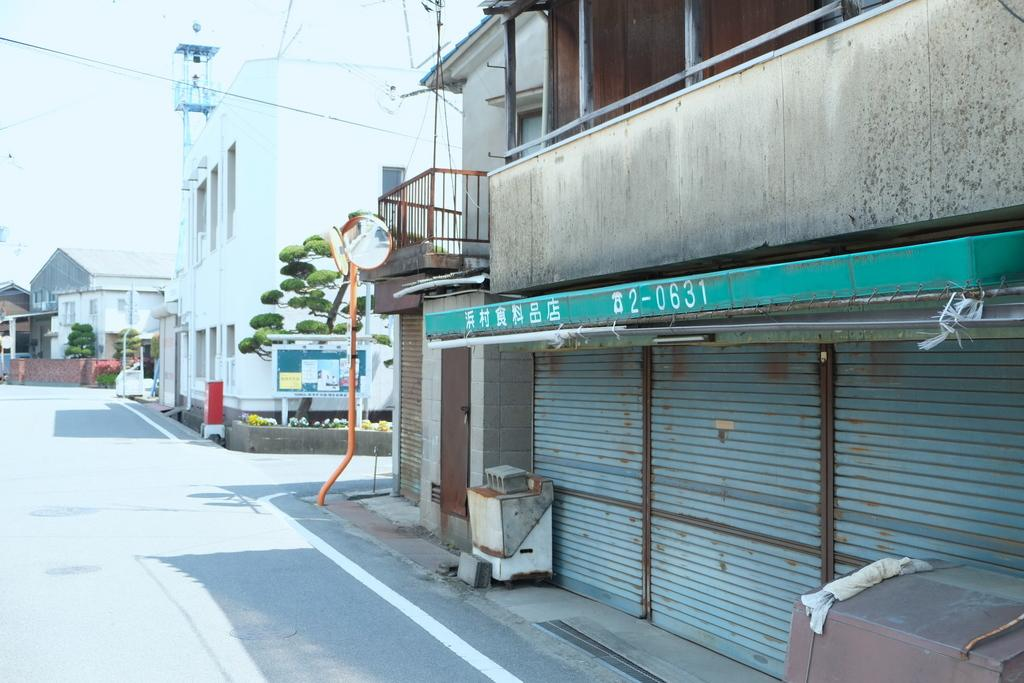What type of structures are present in the image? The image contains buildings. What is located at the bottom of the image? There is a road at the bottom of the image. What can be seen at the top of the image? The sky is visible at the top of the image. Can you describe the vegetation in the image? There is a tree beside a building in the image. What type of window covering is present in the image? There are shutters in the image. How many apples are on the chessboard in the image? There is no chessboard or apples present in the image. What color is the button on the tree in the image? There is no button present in the image. 